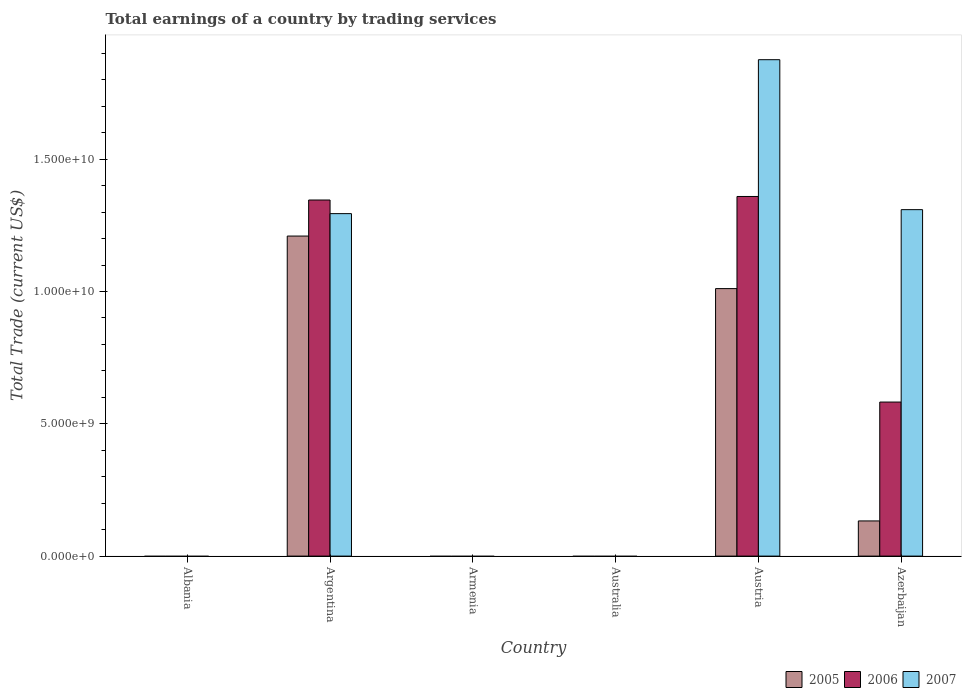How many different coloured bars are there?
Offer a terse response. 3. Are the number of bars per tick equal to the number of legend labels?
Give a very brief answer. No. How many bars are there on the 5th tick from the left?
Provide a succinct answer. 3. In how many cases, is the number of bars for a given country not equal to the number of legend labels?
Ensure brevity in your answer.  3. Across all countries, what is the maximum total earnings in 2005?
Give a very brief answer. 1.21e+1. Across all countries, what is the minimum total earnings in 2007?
Provide a short and direct response. 0. What is the total total earnings in 2007 in the graph?
Give a very brief answer. 4.48e+1. What is the difference between the total earnings in 2007 in Argentina and that in Azerbaijan?
Ensure brevity in your answer.  -1.50e+08. What is the difference between the total earnings in 2005 in Armenia and the total earnings in 2007 in Argentina?
Keep it short and to the point. -1.29e+1. What is the average total earnings in 2007 per country?
Your answer should be compact. 7.47e+09. What is the difference between the total earnings of/in 2005 and total earnings of/in 2007 in Austria?
Provide a short and direct response. -8.65e+09. In how many countries, is the total earnings in 2006 greater than 1000000000 US$?
Offer a very short reply. 3. What is the ratio of the total earnings in 2007 in Austria to that in Azerbaijan?
Offer a very short reply. 1.43. Is the total earnings in 2006 in Austria less than that in Azerbaijan?
Offer a very short reply. No. What is the difference between the highest and the second highest total earnings in 2006?
Your answer should be very brief. -1.34e+08. What is the difference between the highest and the lowest total earnings in 2005?
Make the answer very short. 1.21e+1. Is it the case that in every country, the sum of the total earnings in 2007 and total earnings in 2006 is greater than the total earnings in 2005?
Offer a terse response. No. How many bars are there?
Your answer should be very brief. 9. Are all the bars in the graph horizontal?
Provide a short and direct response. No. How many countries are there in the graph?
Your answer should be compact. 6. What is the difference between two consecutive major ticks on the Y-axis?
Ensure brevity in your answer.  5.00e+09. Are the values on the major ticks of Y-axis written in scientific E-notation?
Your answer should be compact. Yes. Does the graph contain any zero values?
Keep it short and to the point. Yes. Does the graph contain grids?
Ensure brevity in your answer.  No. Where does the legend appear in the graph?
Provide a succinct answer. Bottom right. How many legend labels are there?
Ensure brevity in your answer.  3. What is the title of the graph?
Provide a succinct answer. Total earnings of a country by trading services. Does "1999" appear as one of the legend labels in the graph?
Keep it short and to the point. No. What is the label or title of the Y-axis?
Your response must be concise. Total Trade (current US$). What is the Total Trade (current US$) of 2005 in Albania?
Ensure brevity in your answer.  0. What is the Total Trade (current US$) of 2005 in Argentina?
Ensure brevity in your answer.  1.21e+1. What is the Total Trade (current US$) of 2006 in Argentina?
Your answer should be very brief. 1.35e+1. What is the Total Trade (current US$) in 2007 in Argentina?
Keep it short and to the point. 1.29e+1. What is the Total Trade (current US$) of 2005 in Australia?
Offer a very short reply. 0. What is the Total Trade (current US$) in 2005 in Austria?
Ensure brevity in your answer.  1.01e+1. What is the Total Trade (current US$) of 2006 in Austria?
Provide a succinct answer. 1.36e+1. What is the Total Trade (current US$) of 2007 in Austria?
Provide a succinct answer. 1.88e+1. What is the Total Trade (current US$) in 2005 in Azerbaijan?
Provide a short and direct response. 1.33e+09. What is the Total Trade (current US$) in 2006 in Azerbaijan?
Ensure brevity in your answer.  5.82e+09. What is the Total Trade (current US$) in 2007 in Azerbaijan?
Provide a short and direct response. 1.31e+1. Across all countries, what is the maximum Total Trade (current US$) in 2005?
Keep it short and to the point. 1.21e+1. Across all countries, what is the maximum Total Trade (current US$) in 2006?
Ensure brevity in your answer.  1.36e+1. Across all countries, what is the maximum Total Trade (current US$) of 2007?
Offer a terse response. 1.88e+1. Across all countries, what is the minimum Total Trade (current US$) in 2005?
Your answer should be compact. 0. Across all countries, what is the minimum Total Trade (current US$) of 2006?
Ensure brevity in your answer.  0. What is the total Total Trade (current US$) of 2005 in the graph?
Provide a succinct answer. 2.35e+1. What is the total Total Trade (current US$) of 2006 in the graph?
Give a very brief answer. 3.29e+1. What is the total Total Trade (current US$) of 2007 in the graph?
Your answer should be very brief. 4.48e+1. What is the difference between the Total Trade (current US$) of 2005 in Argentina and that in Austria?
Provide a short and direct response. 1.99e+09. What is the difference between the Total Trade (current US$) of 2006 in Argentina and that in Austria?
Ensure brevity in your answer.  -1.34e+08. What is the difference between the Total Trade (current US$) in 2007 in Argentina and that in Austria?
Your answer should be very brief. -5.82e+09. What is the difference between the Total Trade (current US$) in 2005 in Argentina and that in Azerbaijan?
Provide a short and direct response. 1.08e+1. What is the difference between the Total Trade (current US$) in 2006 in Argentina and that in Azerbaijan?
Your response must be concise. 7.64e+09. What is the difference between the Total Trade (current US$) of 2007 in Argentina and that in Azerbaijan?
Your response must be concise. -1.50e+08. What is the difference between the Total Trade (current US$) of 2005 in Austria and that in Azerbaijan?
Offer a very short reply. 8.78e+09. What is the difference between the Total Trade (current US$) of 2006 in Austria and that in Azerbaijan?
Offer a terse response. 7.77e+09. What is the difference between the Total Trade (current US$) of 2007 in Austria and that in Azerbaijan?
Provide a succinct answer. 5.67e+09. What is the difference between the Total Trade (current US$) in 2005 in Argentina and the Total Trade (current US$) in 2006 in Austria?
Keep it short and to the point. -1.50e+09. What is the difference between the Total Trade (current US$) in 2005 in Argentina and the Total Trade (current US$) in 2007 in Austria?
Provide a succinct answer. -6.67e+09. What is the difference between the Total Trade (current US$) of 2006 in Argentina and the Total Trade (current US$) of 2007 in Austria?
Your response must be concise. -5.30e+09. What is the difference between the Total Trade (current US$) of 2005 in Argentina and the Total Trade (current US$) of 2006 in Azerbaijan?
Keep it short and to the point. 6.27e+09. What is the difference between the Total Trade (current US$) in 2005 in Argentina and the Total Trade (current US$) in 2007 in Azerbaijan?
Offer a terse response. -9.98e+08. What is the difference between the Total Trade (current US$) in 2006 in Argentina and the Total Trade (current US$) in 2007 in Azerbaijan?
Provide a short and direct response. 3.64e+08. What is the difference between the Total Trade (current US$) of 2005 in Austria and the Total Trade (current US$) of 2006 in Azerbaijan?
Offer a very short reply. 4.29e+09. What is the difference between the Total Trade (current US$) of 2005 in Austria and the Total Trade (current US$) of 2007 in Azerbaijan?
Offer a terse response. -2.98e+09. What is the difference between the Total Trade (current US$) in 2006 in Austria and the Total Trade (current US$) in 2007 in Azerbaijan?
Offer a terse response. 4.98e+08. What is the average Total Trade (current US$) in 2005 per country?
Keep it short and to the point. 3.92e+09. What is the average Total Trade (current US$) in 2006 per country?
Provide a succinct answer. 5.48e+09. What is the average Total Trade (current US$) in 2007 per country?
Give a very brief answer. 7.47e+09. What is the difference between the Total Trade (current US$) in 2005 and Total Trade (current US$) in 2006 in Argentina?
Your answer should be very brief. -1.36e+09. What is the difference between the Total Trade (current US$) in 2005 and Total Trade (current US$) in 2007 in Argentina?
Keep it short and to the point. -8.48e+08. What is the difference between the Total Trade (current US$) of 2006 and Total Trade (current US$) of 2007 in Argentina?
Make the answer very short. 5.15e+08. What is the difference between the Total Trade (current US$) of 2005 and Total Trade (current US$) of 2006 in Austria?
Your answer should be very brief. -3.48e+09. What is the difference between the Total Trade (current US$) of 2005 and Total Trade (current US$) of 2007 in Austria?
Offer a very short reply. -8.65e+09. What is the difference between the Total Trade (current US$) of 2006 and Total Trade (current US$) of 2007 in Austria?
Give a very brief answer. -5.17e+09. What is the difference between the Total Trade (current US$) of 2005 and Total Trade (current US$) of 2006 in Azerbaijan?
Give a very brief answer. -4.49e+09. What is the difference between the Total Trade (current US$) of 2005 and Total Trade (current US$) of 2007 in Azerbaijan?
Give a very brief answer. -1.18e+1. What is the difference between the Total Trade (current US$) in 2006 and Total Trade (current US$) in 2007 in Azerbaijan?
Your response must be concise. -7.27e+09. What is the ratio of the Total Trade (current US$) of 2005 in Argentina to that in Austria?
Make the answer very short. 1.2. What is the ratio of the Total Trade (current US$) in 2006 in Argentina to that in Austria?
Give a very brief answer. 0.99. What is the ratio of the Total Trade (current US$) in 2007 in Argentina to that in Austria?
Ensure brevity in your answer.  0.69. What is the ratio of the Total Trade (current US$) in 2005 in Argentina to that in Azerbaijan?
Make the answer very short. 9.1. What is the ratio of the Total Trade (current US$) of 2006 in Argentina to that in Azerbaijan?
Offer a terse response. 2.31. What is the ratio of the Total Trade (current US$) in 2005 in Austria to that in Azerbaijan?
Your response must be concise. 7.61. What is the ratio of the Total Trade (current US$) of 2006 in Austria to that in Azerbaijan?
Make the answer very short. 2.33. What is the ratio of the Total Trade (current US$) of 2007 in Austria to that in Azerbaijan?
Your response must be concise. 1.43. What is the difference between the highest and the second highest Total Trade (current US$) of 2005?
Offer a very short reply. 1.99e+09. What is the difference between the highest and the second highest Total Trade (current US$) of 2006?
Provide a succinct answer. 1.34e+08. What is the difference between the highest and the second highest Total Trade (current US$) of 2007?
Your answer should be very brief. 5.67e+09. What is the difference between the highest and the lowest Total Trade (current US$) in 2005?
Make the answer very short. 1.21e+1. What is the difference between the highest and the lowest Total Trade (current US$) of 2006?
Provide a short and direct response. 1.36e+1. What is the difference between the highest and the lowest Total Trade (current US$) in 2007?
Offer a very short reply. 1.88e+1. 